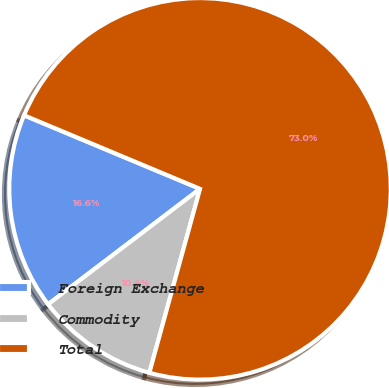Convert chart. <chart><loc_0><loc_0><loc_500><loc_500><pie_chart><fcel>Foreign Exchange<fcel>Commodity<fcel>Total<nl><fcel>16.64%<fcel>10.38%<fcel>72.97%<nl></chart> 